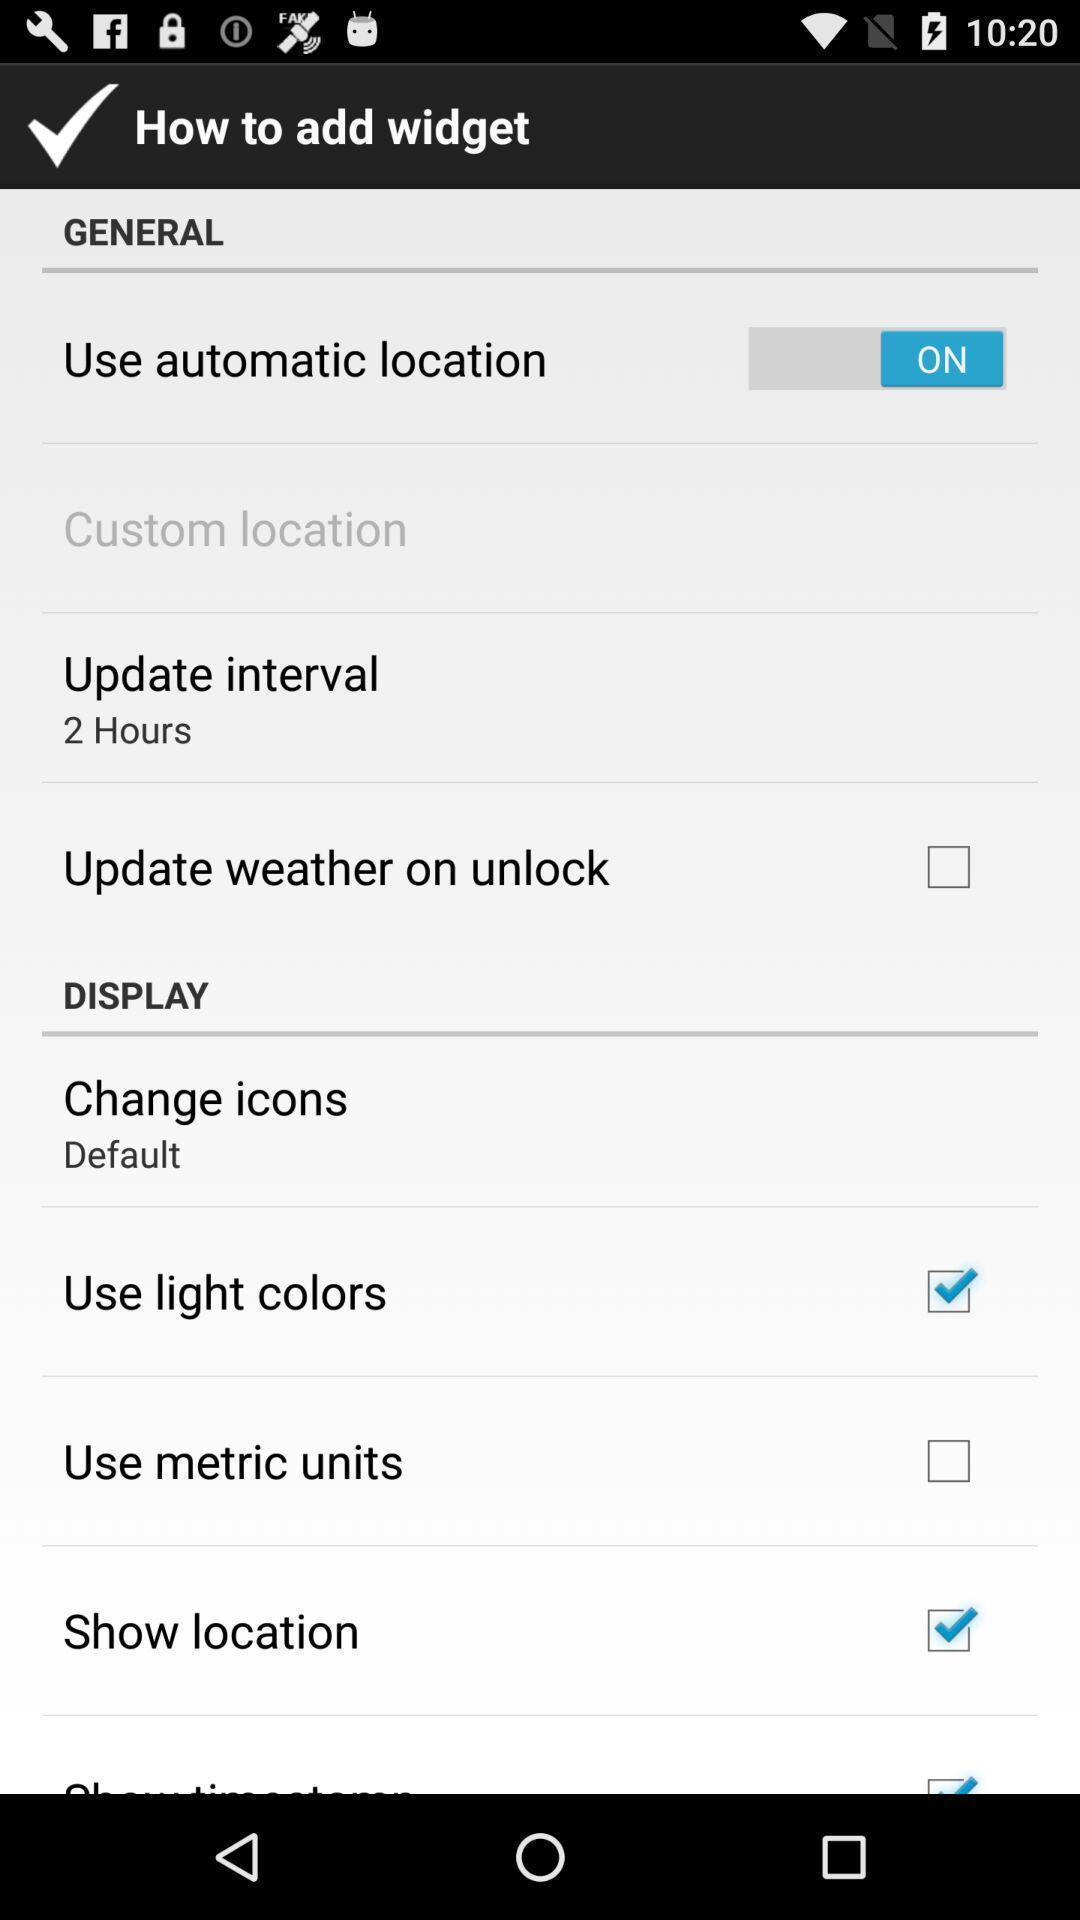Tell me what you see in this picture. Page showing the settings. 